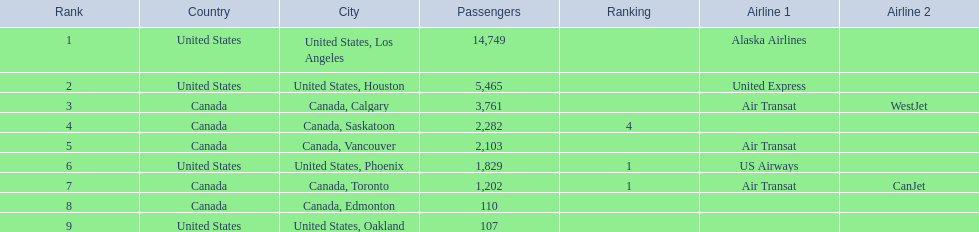Which airport has the least amount of passengers? 107. What airport has 107 passengers? United States, Oakland. 